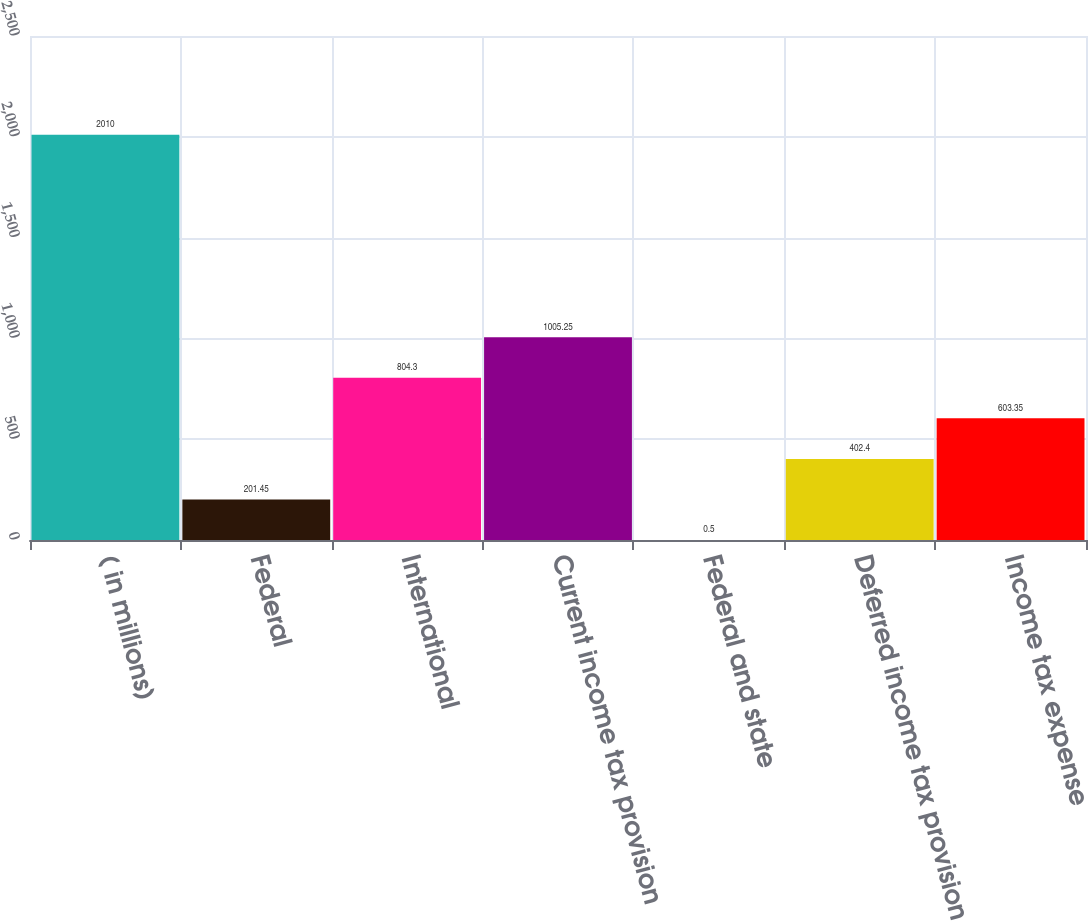Convert chart. <chart><loc_0><loc_0><loc_500><loc_500><bar_chart><fcel>( in millions)<fcel>Federal<fcel>International<fcel>Current income tax provision<fcel>Federal and state<fcel>Deferred income tax provision<fcel>Income tax expense<nl><fcel>2010<fcel>201.45<fcel>804.3<fcel>1005.25<fcel>0.5<fcel>402.4<fcel>603.35<nl></chart> 